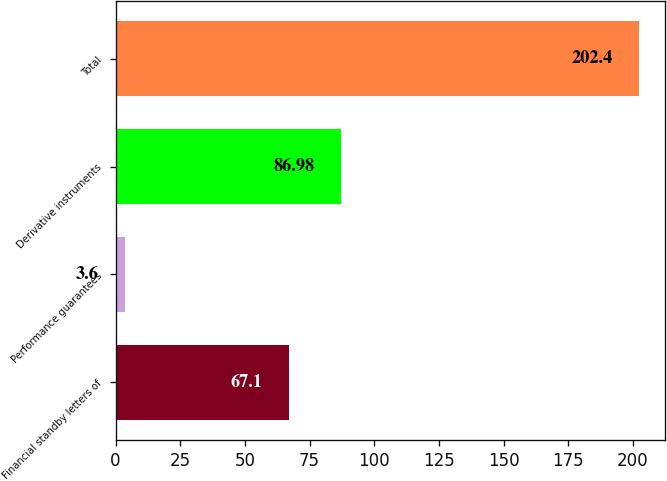Convert chart to OTSL. <chart><loc_0><loc_0><loc_500><loc_500><bar_chart><fcel>Financial standby letters of<fcel>Performance guarantees<fcel>Derivative instruments<fcel>Total<nl><fcel>67.1<fcel>3.6<fcel>86.98<fcel>202.4<nl></chart> 